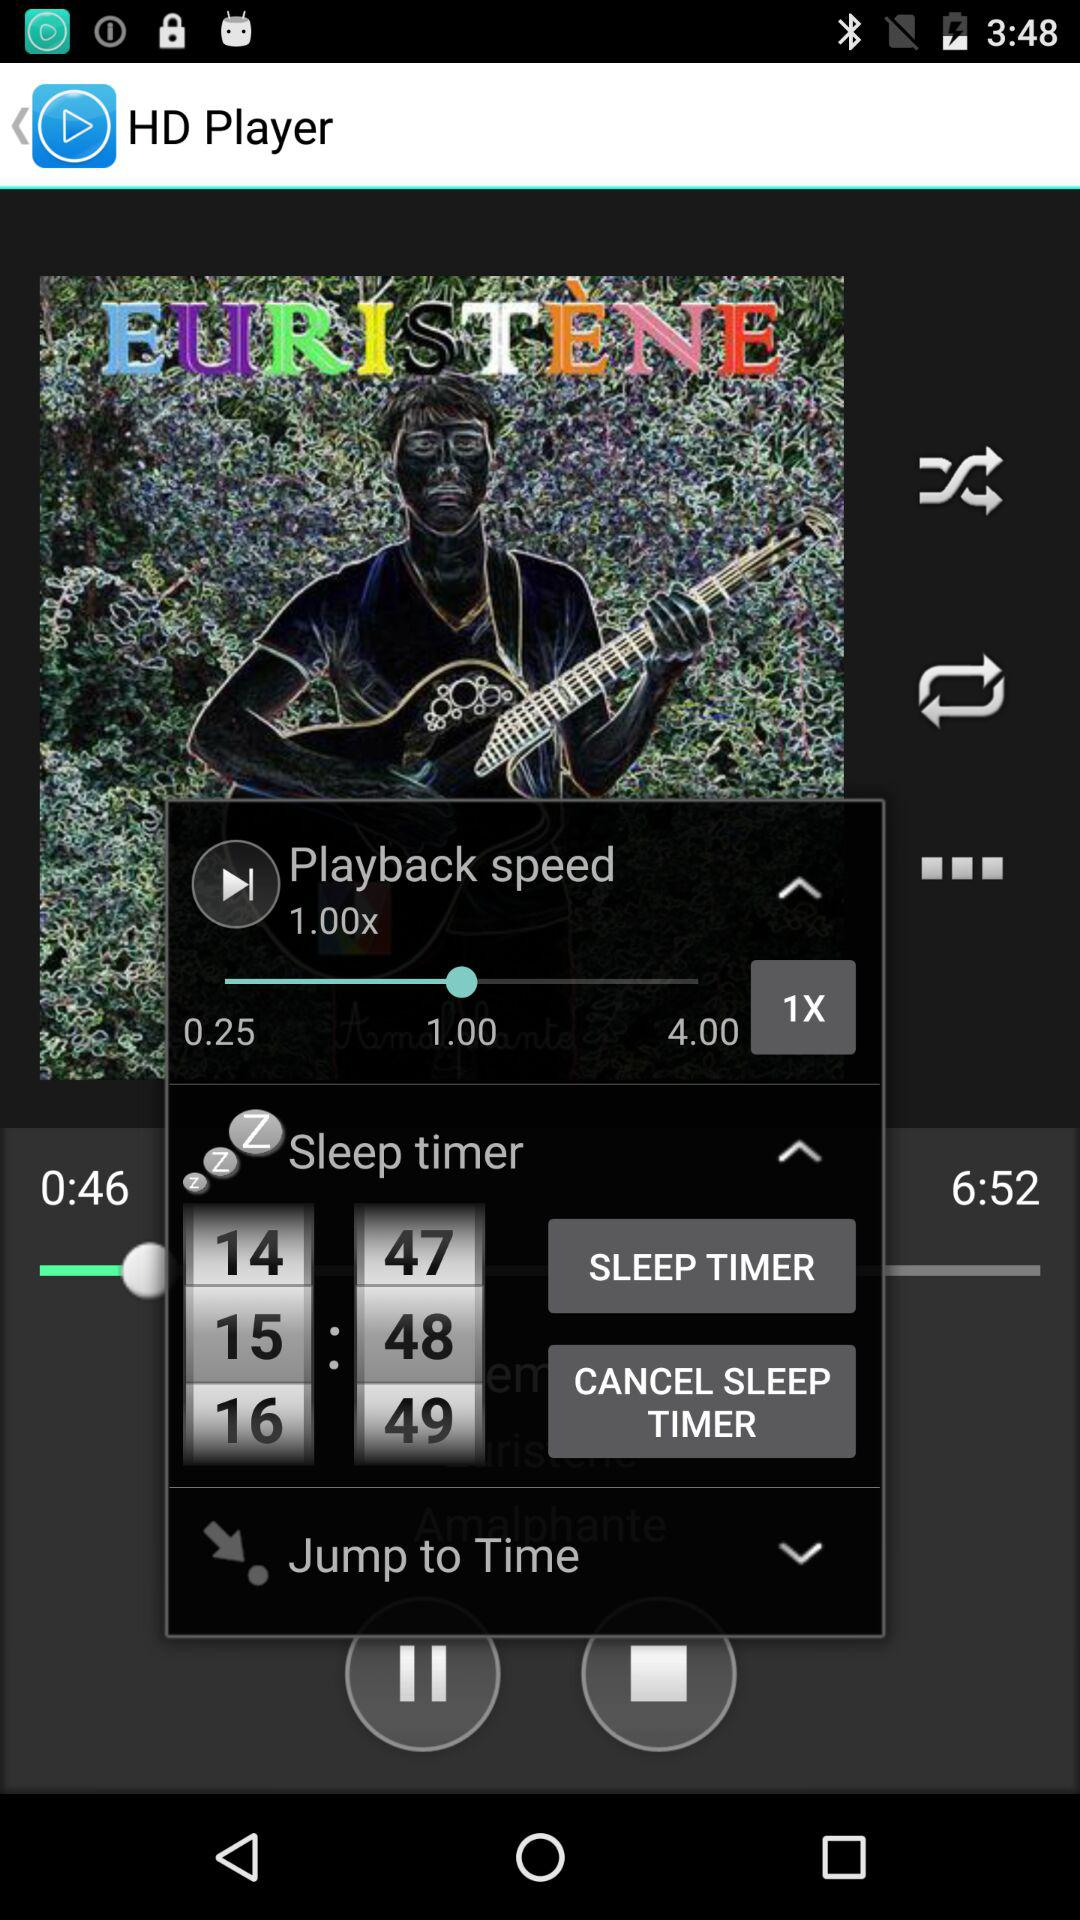What is the playback speed? The playback speed is 1.00. 